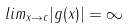Convert formula to latex. <formula><loc_0><loc_0><loc_500><loc_500>l i m _ { x \rightarrow c } | g ( x ) | = \infty</formula> 